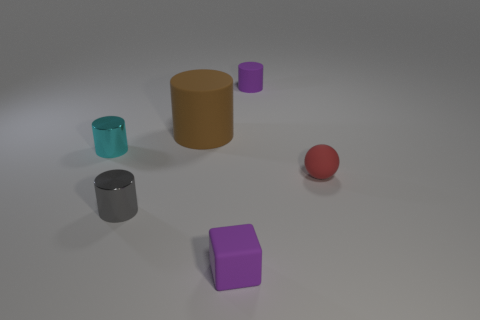What number of purple rubber blocks are in front of the small purple rubber thing that is in front of the purple matte thing behind the tiny purple cube?
Make the answer very short. 0. Does the purple thing left of the small purple cylinder have the same shape as the cyan shiny object?
Your answer should be compact. No. Are there any tiny gray metallic objects that are to the right of the purple rubber thing that is in front of the large brown thing?
Make the answer very short. No. What number of small cyan shiny objects are there?
Make the answer very short. 1. There is a rubber thing that is in front of the brown rubber object and to the left of the red thing; what is its color?
Keep it short and to the point. Purple. The other matte object that is the same shape as the brown rubber thing is what size?
Offer a very short reply. Small. How many purple cylinders are the same size as the brown cylinder?
Give a very brief answer. 0. What is the tiny cyan cylinder made of?
Provide a short and direct response. Metal. Are there any red balls in front of the sphere?
Your answer should be very brief. No. The brown cylinder that is the same material as the purple block is what size?
Offer a very short reply. Large. 